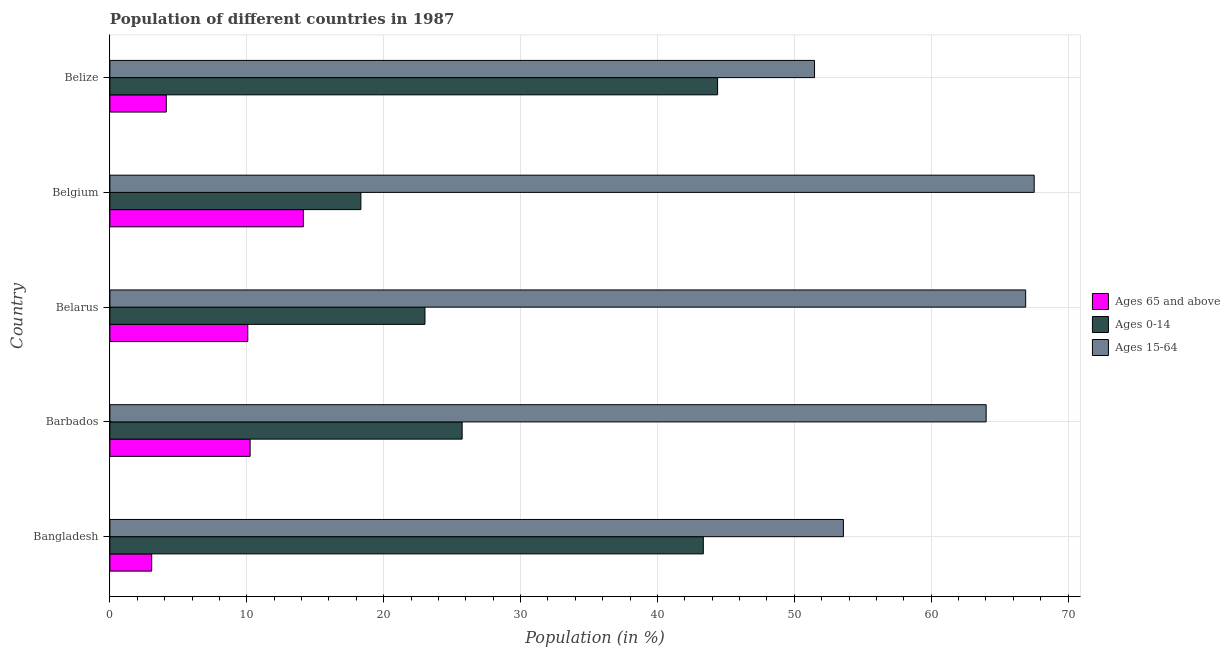How many different coloured bars are there?
Your answer should be compact. 3. How many groups of bars are there?
Make the answer very short. 5. What is the label of the 4th group of bars from the top?
Your answer should be very brief. Barbados. What is the percentage of population within the age-group 0-14 in Barbados?
Offer a very short reply. 25.74. Across all countries, what is the maximum percentage of population within the age-group 15-64?
Make the answer very short. 67.53. Across all countries, what is the minimum percentage of population within the age-group 15-64?
Keep it short and to the point. 51.48. In which country was the percentage of population within the age-group 0-14 maximum?
Your answer should be very brief. Belize. In which country was the percentage of population within the age-group 15-64 minimum?
Ensure brevity in your answer.  Belize. What is the total percentage of population within the age-group 15-64 in the graph?
Your response must be concise. 303.52. What is the difference between the percentage of population within the age-group 0-14 in Barbados and that in Belarus?
Your answer should be very brief. 2.72. What is the difference between the percentage of population within the age-group 15-64 in Belgium and the percentage of population within the age-group 0-14 in Barbados?
Provide a short and direct response. 41.79. What is the average percentage of population within the age-group 0-14 per country?
Your response must be concise. 30.97. What is the difference between the percentage of population within the age-group 15-64 and percentage of population within the age-group of 65 and above in Belgium?
Your answer should be very brief. 53.4. Is the percentage of population within the age-group of 65 and above in Belgium less than that in Belize?
Offer a terse response. No. Is the difference between the percentage of population within the age-group 15-64 in Belarus and Belize greater than the difference between the percentage of population within the age-group of 65 and above in Belarus and Belize?
Keep it short and to the point. Yes. What is the difference between the highest and the second highest percentage of population within the age-group 0-14?
Ensure brevity in your answer.  1.04. What is the difference between the highest and the lowest percentage of population within the age-group 0-14?
Give a very brief answer. 26.06. What does the 1st bar from the top in Bangladesh represents?
Provide a short and direct response. Ages 15-64. What does the 1st bar from the bottom in Barbados represents?
Keep it short and to the point. Ages 65 and above. Is it the case that in every country, the sum of the percentage of population within the age-group of 65 and above and percentage of population within the age-group 0-14 is greater than the percentage of population within the age-group 15-64?
Keep it short and to the point. No. What is the difference between two consecutive major ticks on the X-axis?
Your answer should be very brief. 10. Where does the legend appear in the graph?
Keep it short and to the point. Center right. How many legend labels are there?
Your answer should be compact. 3. How are the legend labels stacked?
Give a very brief answer. Vertical. What is the title of the graph?
Your answer should be very brief. Population of different countries in 1987. What is the label or title of the Y-axis?
Give a very brief answer. Country. What is the Population (in %) of Ages 65 and above in Bangladesh?
Your answer should be very brief. 3.06. What is the Population (in %) of Ages 0-14 in Bangladesh?
Provide a succinct answer. 43.36. What is the Population (in %) of Ages 15-64 in Bangladesh?
Keep it short and to the point. 53.59. What is the Population (in %) in Ages 65 and above in Barbados?
Keep it short and to the point. 10.25. What is the Population (in %) of Ages 0-14 in Barbados?
Give a very brief answer. 25.74. What is the Population (in %) of Ages 15-64 in Barbados?
Provide a succinct answer. 64.02. What is the Population (in %) in Ages 65 and above in Belarus?
Keep it short and to the point. 10.07. What is the Population (in %) in Ages 0-14 in Belarus?
Offer a terse response. 23.02. What is the Population (in %) of Ages 15-64 in Belarus?
Provide a succinct answer. 66.91. What is the Population (in %) of Ages 65 and above in Belgium?
Your response must be concise. 14.13. What is the Population (in %) in Ages 0-14 in Belgium?
Provide a succinct answer. 18.34. What is the Population (in %) in Ages 15-64 in Belgium?
Provide a short and direct response. 67.53. What is the Population (in %) of Ages 65 and above in Belize?
Give a very brief answer. 4.12. What is the Population (in %) in Ages 0-14 in Belize?
Provide a short and direct response. 44.4. What is the Population (in %) in Ages 15-64 in Belize?
Offer a terse response. 51.48. Across all countries, what is the maximum Population (in %) of Ages 65 and above?
Offer a terse response. 14.13. Across all countries, what is the maximum Population (in %) of Ages 0-14?
Make the answer very short. 44.4. Across all countries, what is the maximum Population (in %) in Ages 15-64?
Offer a terse response. 67.53. Across all countries, what is the minimum Population (in %) in Ages 65 and above?
Your answer should be very brief. 3.06. Across all countries, what is the minimum Population (in %) of Ages 0-14?
Make the answer very short. 18.34. Across all countries, what is the minimum Population (in %) of Ages 15-64?
Your answer should be very brief. 51.48. What is the total Population (in %) of Ages 65 and above in the graph?
Your response must be concise. 41.63. What is the total Population (in %) in Ages 0-14 in the graph?
Your answer should be compact. 154.85. What is the total Population (in %) of Ages 15-64 in the graph?
Keep it short and to the point. 303.52. What is the difference between the Population (in %) of Ages 65 and above in Bangladesh and that in Barbados?
Your answer should be compact. -7.19. What is the difference between the Population (in %) of Ages 0-14 in Bangladesh and that in Barbados?
Your answer should be very brief. 17.62. What is the difference between the Population (in %) of Ages 15-64 in Bangladesh and that in Barbados?
Provide a short and direct response. -10.43. What is the difference between the Population (in %) in Ages 65 and above in Bangladesh and that in Belarus?
Make the answer very short. -7.02. What is the difference between the Population (in %) of Ages 0-14 in Bangladesh and that in Belarus?
Offer a very short reply. 20.34. What is the difference between the Population (in %) in Ages 15-64 in Bangladesh and that in Belarus?
Offer a terse response. -13.32. What is the difference between the Population (in %) in Ages 65 and above in Bangladesh and that in Belgium?
Give a very brief answer. -11.08. What is the difference between the Population (in %) of Ages 0-14 in Bangladesh and that in Belgium?
Offer a terse response. 25.02. What is the difference between the Population (in %) in Ages 15-64 in Bangladesh and that in Belgium?
Provide a succinct answer. -13.94. What is the difference between the Population (in %) in Ages 65 and above in Bangladesh and that in Belize?
Your answer should be very brief. -1.06. What is the difference between the Population (in %) in Ages 0-14 in Bangladesh and that in Belize?
Provide a succinct answer. -1.04. What is the difference between the Population (in %) in Ages 15-64 in Bangladesh and that in Belize?
Keep it short and to the point. 2.11. What is the difference between the Population (in %) of Ages 65 and above in Barbados and that in Belarus?
Your answer should be compact. 0.17. What is the difference between the Population (in %) in Ages 0-14 in Barbados and that in Belarus?
Offer a very short reply. 2.72. What is the difference between the Population (in %) in Ages 15-64 in Barbados and that in Belarus?
Your response must be concise. -2.89. What is the difference between the Population (in %) in Ages 65 and above in Barbados and that in Belgium?
Your response must be concise. -3.89. What is the difference between the Population (in %) in Ages 0-14 in Barbados and that in Belgium?
Keep it short and to the point. 7.4. What is the difference between the Population (in %) of Ages 15-64 in Barbados and that in Belgium?
Offer a terse response. -3.51. What is the difference between the Population (in %) of Ages 65 and above in Barbados and that in Belize?
Offer a very short reply. 6.13. What is the difference between the Population (in %) of Ages 0-14 in Barbados and that in Belize?
Ensure brevity in your answer.  -18.66. What is the difference between the Population (in %) of Ages 15-64 in Barbados and that in Belize?
Provide a succinct answer. 12.54. What is the difference between the Population (in %) of Ages 65 and above in Belarus and that in Belgium?
Keep it short and to the point. -4.06. What is the difference between the Population (in %) in Ages 0-14 in Belarus and that in Belgium?
Offer a very short reply. 4.68. What is the difference between the Population (in %) in Ages 15-64 in Belarus and that in Belgium?
Make the answer very short. -0.62. What is the difference between the Population (in %) of Ages 65 and above in Belarus and that in Belize?
Your answer should be very brief. 5.95. What is the difference between the Population (in %) of Ages 0-14 in Belarus and that in Belize?
Provide a short and direct response. -21.38. What is the difference between the Population (in %) in Ages 15-64 in Belarus and that in Belize?
Make the answer very short. 15.43. What is the difference between the Population (in %) in Ages 65 and above in Belgium and that in Belize?
Provide a succinct answer. 10.01. What is the difference between the Population (in %) in Ages 0-14 in Belgium and that in Belize?
Offer a terse response. -26.06. What is the difference between the Population (in %) of Ages 15-64 in Belgium and that in Belize?
Offer a very short reply. 16.05. What is the difference between the Population (in %) in Ages 65 and above in Bangladesh and the Population (in %) in Ages 0-14 in Barbados?
Make the answer very short. -22.68. What is the difference between the Population (in %) of Ages 65 and above in Bangladesh and the Population (in %) of Ages 15-64 in Barbados?
Provide a short and direct response. -60.96. What is the difference between the Population (in %) in Ages 0-14 in Bangladesh and the Population (in %) in Ages 15-64 in Barbados?
Offer a very short reply. -20.66. What is the difference between the Population (in %) in Ages 65 and above in Bangladesh and the Population (in %) in Ages 0-14 in Belarus?
Keep it short and to the point. -19.96. What is the difference between the Population (in %) in Ages 65 and above in Bangladesh and the Population (in %) in Ages 15-64 in Belarus?
Provide a succinct answer. -63.85. What is the difference between the Population (in %) in Ages 0-14 in Bangladesh and the Population (in %) in Ages 15-64 in Belarus?
Your response must be concise. -23.55. What is the difference between the Population (in %) in Ages 65 and above in Bangladesh and the Population (in %) in Ages 0-14 in Belgium?
Give a very brief answer. -15.28. What is the difference between the Population (in %) in Ages 65 and above in Bangladesh and the Population (in %) in Ages 15-64 in Belgium?
Your answer should be very brief. -64.47. What is the difference between the Population (in %) of Ages 0-14 in Bangladesh and the Population (in %) of Ages 15-64 in Belgium?
Provide a succinct answer. -24.17. What is the difference between the Population (in %) of Ages 65 and above in Bangladesh and the Population (in %) of Ages 0-14 in Belize?
Make the answer very short. -41.34. What is the difference between the Population (in %) of Ages 65 and above in Bangladesh and the Population (in %) of Ages 15-64 in Belize?
Your answer should be compact. -48.43. What is the difference between the Population (in %) in Ages 0-14 in Bangladesh and the Population (in %) in Ages 15-64 in Belize?
Your answer should be compact. -8.13. What is the difference between the Population (in %) of Ages 65 and above in Barbados and the Population (in %) of Ages 0-14 in Belarus?
Your answer should be compact. -12.77. What is the difference between the Population (in %) in Ages 65 and above in Barbados and the Population (in %) in Ages 15-64 in Belarus?
Ensure brevity in your answer.  -56.66. What is the difference between the Population (in %) in Ages 0-14 in Barbados and the Population (in %) in Ages 15-64 in Belarus?
Offer a very short reply. -41.17. What is the difference between the Population (in %) of Ages 65 and above in Barbados and the Population (in %) of Ages 0-14 in Belgium?
Ensure brevity in your answer.  -8.09. What is the difference between the Population (in %) in Ages 65 and above in Barbados and the Population (in %) in Ages 15-64 in Belgium?
Give a very brief answer. -57.28. What is the difference between the Population (in %) of Ages 0-14 in Barbados and the Population (in %) of Ages 15-64 in Belgium?
Offer a very short reply. -41.79. What is the difference between the Population (in %) of Ages 65 and above in Barbados and the Population (in %) of Ages 0-14 in Belize?
Provide a succinct answer. -34.15. What is the difference between the Population (in %) in Ages 65 and above in Barbados and the Population (in %) in Ages 15-64 in Belize?
Your response must be concise. -41.24. What is the difference between the Population (in %) of Ages 0-14 in Barbados and the Population (in %) of Ages 15-64 in Belize?
Your answer should be very brief. -25.74. What is the difference between the Population (in %) of Ages 65 and above in Belarus and the Population (in %) of Ages 0-14 in Belgium?
Make the answer very short. -8.26. What is the difference between the Population (in %) in Ages 65 and above in Belarus and the Population (in %) in Ages 15-64 in Belgium?
Give a very brief answer. -57.46. What is the difference between the Population (in %) of Ages 0-14 in Belarus and the Population (in %) of Ages 15-64 in Belgium?
Make the answer very short. -44.51. What is the difference between the Population (in %) of Ages 65 and above in Belarus and the Population (in %) of Ages 0-14 in Belize?
Ensure brevity in your answer.  -34.33. What is the difference between the Population (in %) in Ages 65 and above in Belarus and the Population (in %) in Ages 15-64 in Belize?
Offer a very short reply. -41.41. What is the difference between the Population (in %) of Ages 0-14 in Belarus and the Population (in %) of Ages 15-64 in Belize?
Offer a terse response. -28.46. What is the difference between the Population (in %) in Ages 65 and above in Belgium and the Population (in %) in Ages 0-14 in Belize?
Give a very brief answer. -30.27. What is the difference between the Population (in %) of Ages 65 and above in Belgium and the Population (in %) of Ages 15-64 in Belize?
Your answer should be very brief. -37.35. What is the difference between the Population (in %) in Ages 0-14 in Belgium and the Population (in %) in Ages 15-64 in Belize?
Make the answer very short. -33.14. What is the average Population (in %) of Ages 65 and above per country?
Ensure brevity in your answer.  8.33. What is the average Population (in %) of Ages 0-14 per country?
Give a very brief answer. 30.97. What is the average Population (in %) in Ages 15-64 per country?
Provide a short and direct response. 60.7. What is the difference between the Population (in %) in Ages 65 and above and Population (in %) in Ages 0-14 in Bangladesh?
Offer a very short reply. -40.3. What is the difference between the Population (in %) in Ages 65 and above and Population (in %) in Ages 15-64 in Bangladesh?
Your response must be concise. -50.53. What is the difference between the Population (in %) of Ages 0-14 and Population (in %) of Ages 15-64 in Bangladesh?
Provide a short and direct response. -10.23. What is the difference between the Population (in %) of Ages 65 and above and Population (in %) of Ages 0-14 in Barbados?
Provide a succinct answer. -15.49. What is the difference between the Population (in %) in Ages 65 and above and Population (in %) in Ages 15-64 in Barbados?
Make the answer very short. -53.77. What is the difference between the Population (in %) in Ages 0-14 and Population (in %) in Ages 15-64 in Barbados?
Offer a terse response. -38.28. What is the difference between the Population (in %) of Ages 65 and above and Population (in %) of Ages 0-14 in Belarus?
Your answer should be compact. -12.95. What is the difference between the Population (in %) in Ages 65 and above and Population (in %) in Ages 15-64 in Belarus?
Give a very brief answer. -56.83. What is the difference between the Population (in %) of Ages 0-14 and Population (in %) of Ages 15-64 in Belarus?
Your answer should be compact. -43.89. What is the difference between the Population (in %) of Ages 65 and above and Population (in %) of Ages 0-14 in Belgium?
Keep it short and to the point. -4.2. What is the difference between the Population (in %) in Ages 65 and above and Population (in %) in Ages 15-64 in Belgium?
Provide a succinct answer. -53.4. What is the difference between the Population (in %) of Ages 0-14 and Population (in %) of Ages 15-64 in Belgium?
Your answer should be very brief. -49.19. What is the difference between the Population (in %) in Ages 65 and above and Population (in %) in Ages 0-14 in Belize?
Your answer should be compact. -40.28. What is the difference between the Population (in %) of Ages 65 and above and Population (in %) of Ages 15-64 in Belize?
Offer a terse response. -47.36. What is the difference between the Population (in %) of Ages 0-14 and Population (in %) of Ages 15-64 in Belize?
Provide a succinct answer. -7.08. What is the ratio of the Population (in %) in Ages 65 and above in Bangladesh to that in Barbados?
Give a very brief answer. 0.3. What is the ratio of the Population (in %) of Ages 0-14 in Bangladesh to that in Barbados?
Offer a very short reply. 1.68. What is the ratio of the Population (in %) in Ages 15-64 in Bangladesh to that in Barbados?
Offer a terse response. 0.84. What is the ratio of the Population (in %) in Ages 65 and above in Bangladesh to that in Belarus?
Give a very brief answer. 0.3. What is the ratio of the Population (in %) in Ages 0-14 in Bangladesh to that in Belarus?
Offer a terse response. 1.88. What is the ratio of the Population (in %) of Ages 15-64 in Bangladesh to that in Belarus?
Provide a succinct answer. 0.8. What is the ratio of the Population (in %) in Ages 65 and above in Bangladesh to that in Belgium?
Offer a very short reply. 0.22. What is the ratio of the Population (in %) in Ages 0-14 in Bangladesh to that in Belgium?
Give a very brief answer. 2.36. What is the ratio of the Population (in %) of Ages 15-64 in Bangladesh to that in Belgium?
Provide a succinct answer. 0.79. What is the ratio of the Population (in %) of Ages 65 and above in Bangladesh to that in Belize?
Give a very brief answer. 0.74. What is the ratio of the Population (in %) of Ages 0-14 in Bangladesh to that in Belize?
Give a very brief answer. 0.98. What is the ratio of the Population (in %) of Ages 15-64 in Bangladesh to that in Belize?
Make the answer very short. 1.04. What is the ratio of the Population (in %) in Ages 65 and above in Barbados to that in Belarus?
Your answer should be compact. 1.02. What is the ratio of the Population (in %) of Ages 0-14 in Barbados to that in Belarus?
Make the answer very short. 1.12. What is the ratio of the Population (in %) in Ages 15-64 in Barbados to that in Belarus?
Make the answer very short. 0.96. What is the ratio of the Population (in %) in Ages 65 and above in Barbados to that in Belgium?
Keep it short and to the point. 0.72. What is the ratio of the Population (in %) of Ages 0-14 in Barbados to that in Belgium?
Offer a terse response. 1.4. What is the ratio of the Population (in %) of Ages 15-64 in Barbados to that in Belgium?
Your response must be concise. 0.95. What is the ratio of the Population (in %) in Ages 65 and above in Barbados to that in Belize?
Give a very brief answer. 2.49. What is the ratio of the Population (in %) of Ages 0-14 in Barbados to that in Belize?
Give a very brief answer. 0.58. What is the ratio of the Population (in %) of Ages 15-64 in Barbados to that in Belize?
Give a very brief answer. 1.24. What is the ratio of the Population (in %) in Ages 65 and above in Belarus to that in Belgium?
Give a very brief answer. 0.71. What is the ratio of the Population (in %) of Ages 0-14 in Belarus to that in Belgium?
Offer a very short reply. 1.26. What is the ratio of the Population (in %) of Ages 15-64 in Belarus to that in Belgium?
Ensure brevity in your answer.  0.99. What is the ratio of the Population (in %) of Ages 65 and above in Belarus to that in Belize?
Your answer should be compact. 2.45. What is the ratio of the Population (in %) in Ages 0-14 in Belarus to that in Belize?
Keep it short and to the point. 0.52. What is the ratio of the Population (in %) in Ages 15-64 in Belarus to that in Belize?
Make the answer very short. 1.3. What is the ratio of the Population (in %) of Ages 65 and above in Belgium to that in Belize?
Make the answer very short. 3.43. What is the ratio of the Population (in %) of Ages 0-14 in Belgium to that in Belize?
Give a very brief answer. 0.41. What is the ratio of the Population (in %) of Ages 15-64 in Belgium to that in Belize?
Give a very brief answer. 1.31. What is the difference between the highest and the second highest Population (in %) in Ages 65 and above?
Keep it short and to the point. 3.89. What is the difference between the highest and the second highest Population (in %) of Ages 0-14?
Your answer should be compact. 1.04. What is the difference between the highest and the second highest Population (in %) in Ages 15-64?
Give a very brief answer. 0.62. What is the difference between the highest and the lowest Population (in %) of Ages 65 and above?
Offer a very short reply. 11.08. What is the difference between the highest and the lowest Population (in %) in Ages 0-14?
Offer a very short reply. 26.06. What is the difference between the highest and the lowest Population (in %) in Ages 15-64?
Give a very brief answer. 16.05. 